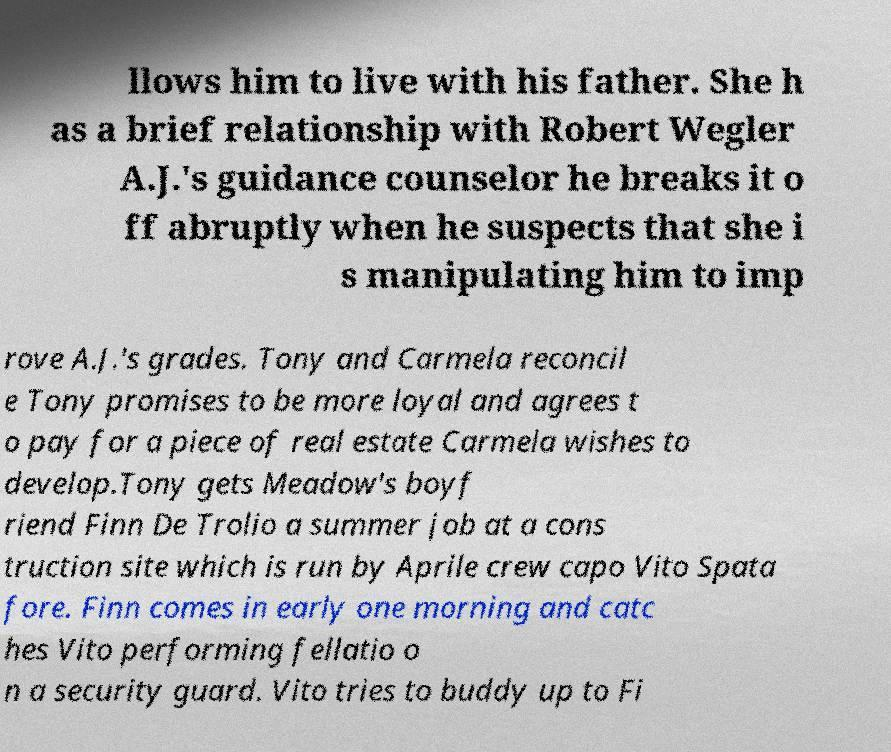Can you accurately transcribe the text from the provided image for me? llows him to live with his father. She h as a brief relationship with Robert Wegler A.J.'s guidance counselor he breaks it o ff abruptly when he suspects that she i s manipulating him to imp rove A.J.'s grades. Tony and Carmela reconcil e Tony promises to be more loyal and agrees t o pay for a piece of real estate Carmela wishes to develop.Tony gets Meadow's boyf riend Finn De Trolio a summer job at a cons truction site which is run by Aprile crew capo Vito Spata fore. Finn comes in early one morning and catc hes Vito performing fellatio o n a security guard. Vito tries to buddy up to Fi 